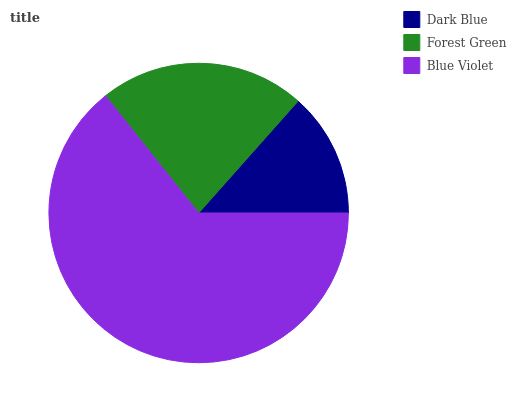Is Dark Blue the minimum?
Answer yes or no. Yes. Is Blue Violet the maximum?
Answer yes or no. Yes. Is Forest Green the minimum?
Answer yes or no. No. Is Forest Green the maximum?
Answer yes or no. No. Is Forest Green greater than Dark Blue?
Answer yes or no. Yes. Is Dark Blue less than Forest Green?
Answer yes or no. Yes. Is Dark Blue greater than Forest Green?
Answer yes or no. No. Is Forest Green less than Dark Blue?
Answer yes or no. No. Is Forest Green the high median?
Answer yes or no. Yes. Is Forest Green the low median?
Answer yes or no. Yes. Is Blue Violet the high median?
Answer yes or no. No. Is Dark Blue the low median?
Answer yes or no. No. 